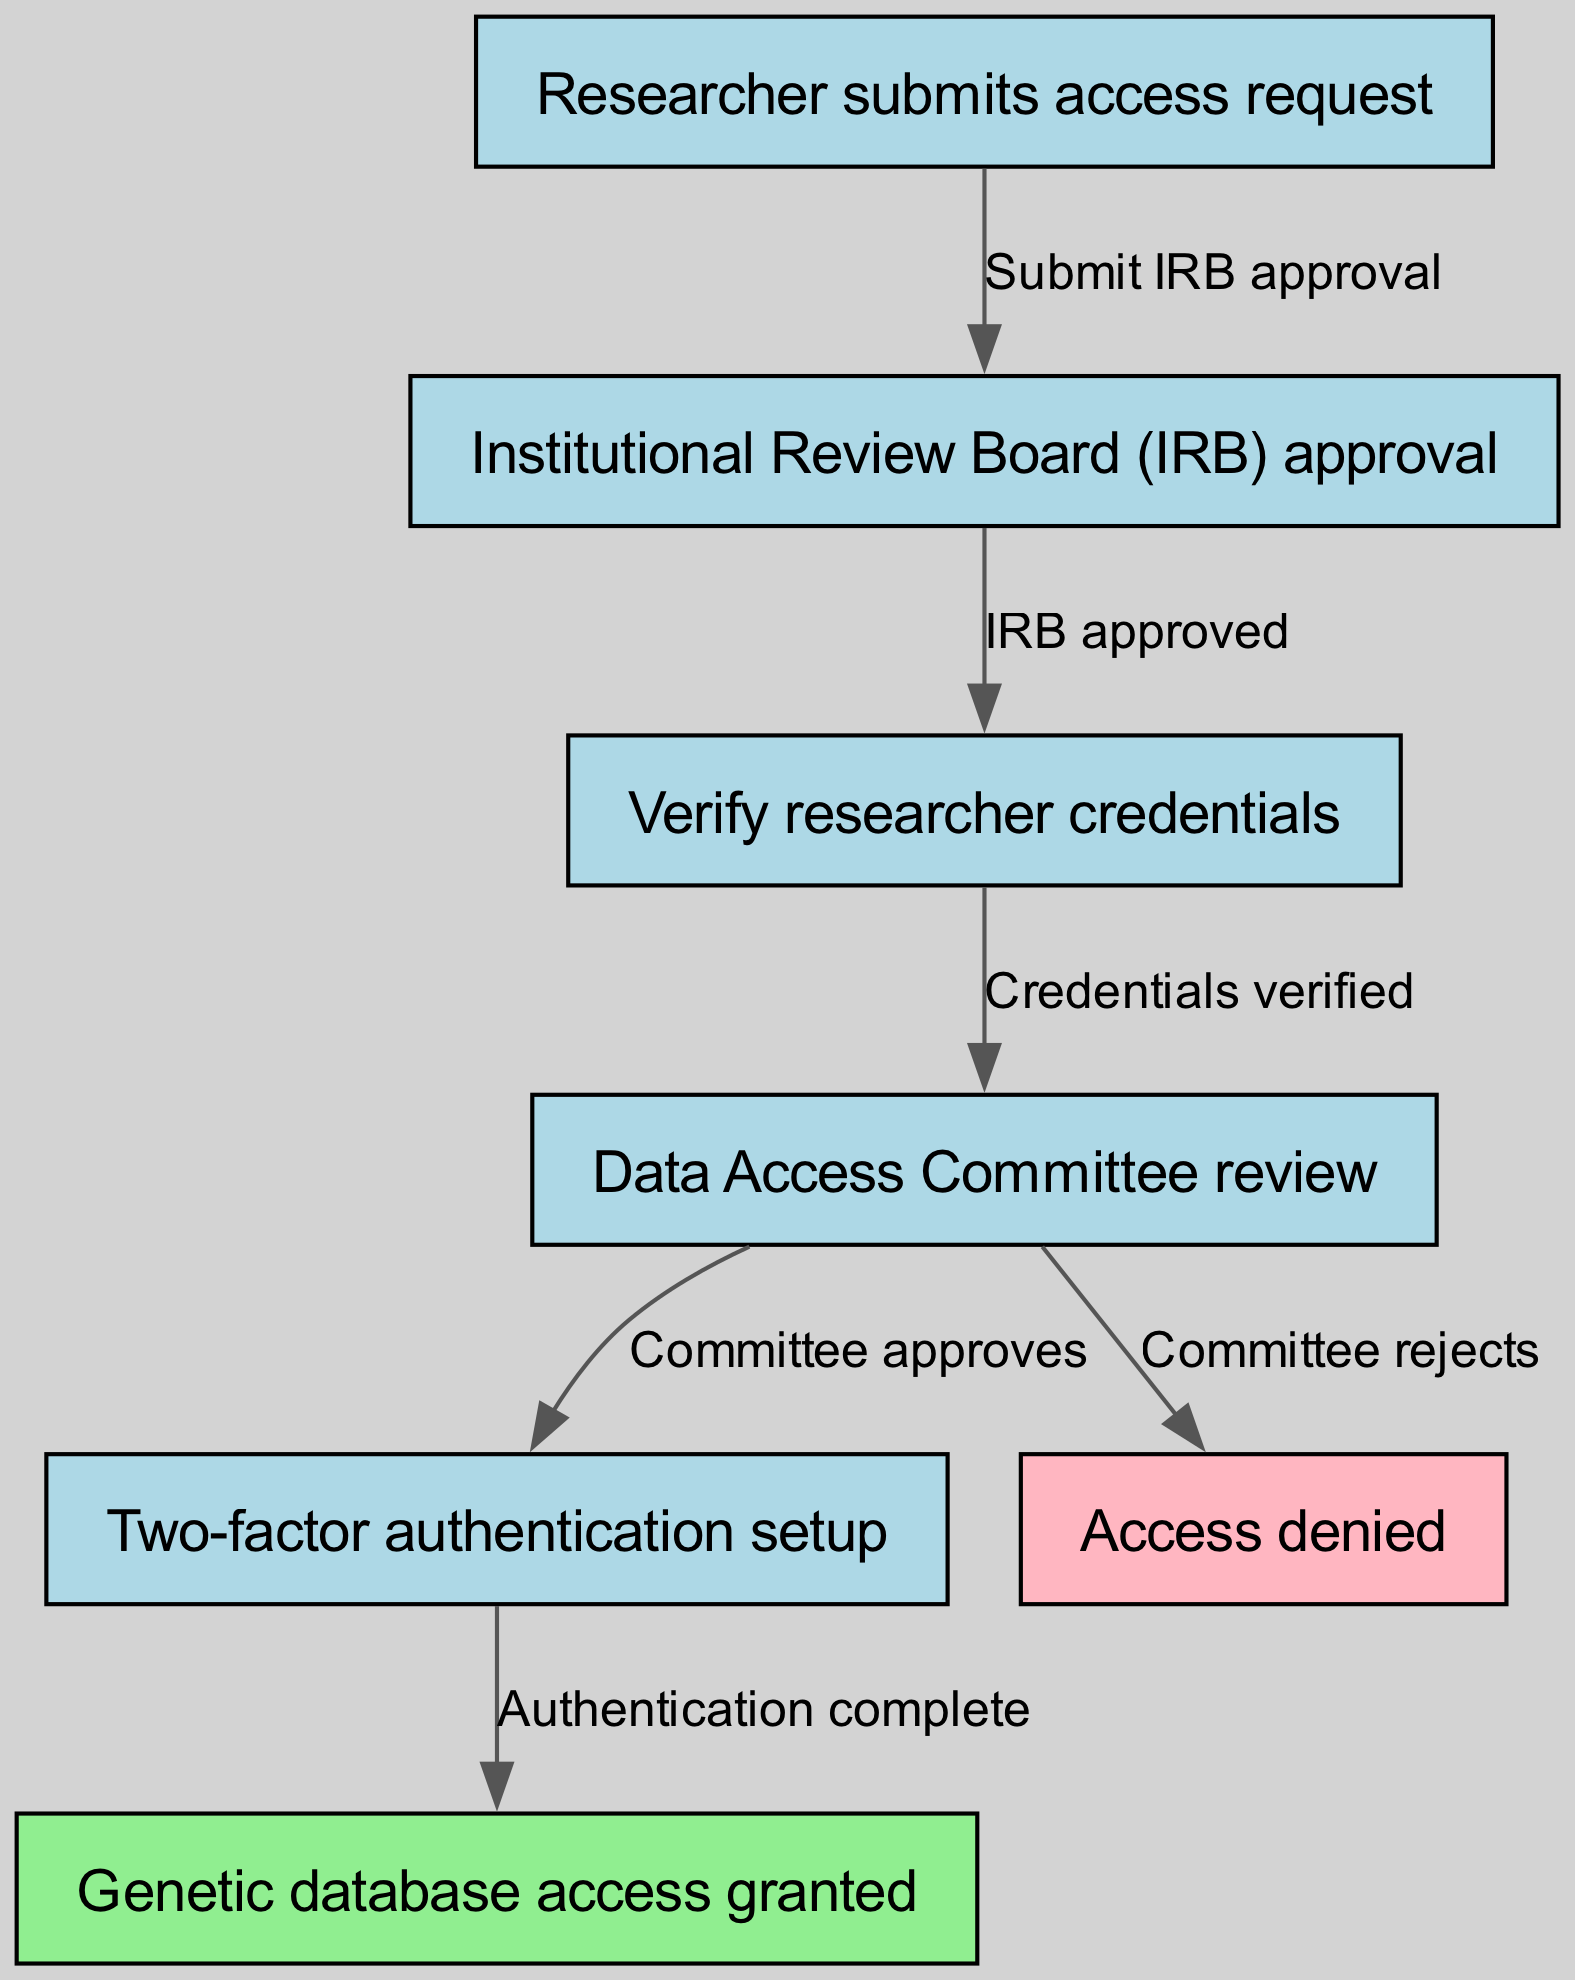What is the first step in the identity verification process? The diagram shows that the process begins with the "Researcher submits access request." This can be identified as the starting node in the pathway, indicating the initiation of the verification process.
Answer: Researcher submits access request How many total nodes are in the diagram? By counting the nodes presented in the diagram, we have a total of 7 nodes: one for each step in the verification process plus the "Access denied" and "Genetic database access granted" terminal nodes.
Answer: 7 What happens after the Institutional Review Board approval? According to the diagram, once the Institutional Review Board approval is granted, the next step is to "Verify researcher credentials." This establishes the flow from approval to credential verification directly.
Answer: Verify researcher credentials What is the outcome if the Data Access Committee rejects the request? The diagram indicates that if the Data Access Committee does not approve the request, the outcome is "Access denied." This node serves as the terminal point for failed requests.
Answer: Access denied What must be completed before genetic database access is granted? The pathway shows that "Two-factor authentication setup" must be completed, following the approval from the Data Access Committee, before access to the genetic database can be granted. This indicates the necessity of authentication as a security measure.
Answer: Authentication complete What denotes the successful completion of the verification process? The successful completion of the identity verification process is indicated by the node "Genetic database access granted." This node comes after the completion of two-factor authentication, signifying the final outcome of the process.
Answer: Genetic database access granted What is the connecting action between verifying credentials and the Data Access Committee review? The connection is established by the action "Credentials verified," which indicates that once the credentials are verified, the next logical step is to undergo a review by the Data Access Committee. This linkage shows the relationship between the verification of credentials and the committee’s review process.
Answer: Credentials verified Who completes the two-factor authentication setup? Although the diagram does not explicitly mention who sets up the two-factor authentication, it is implied that it is the researcher who would complete this step after receiving approval from the Data Access Committee, as part of the overall access request processing.
Answer: Researcher (implied) 